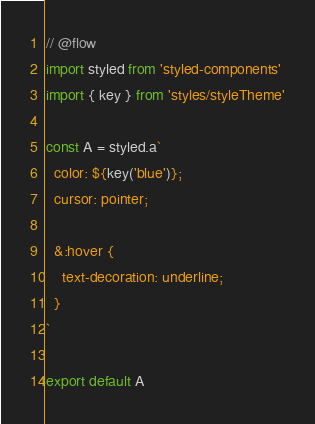<code> <loc_0><loc_0><loc_500><loc_500><_JavaScript_>// @flow
import styled from 'styled-components'
import { key } from 'styles/styleTheme'

const A = styled.a`
  color: ${key('blue')};
  cursor: pointer;

  &:hover {
    text-decoration: underline;
  }
`

export default A
</code> 